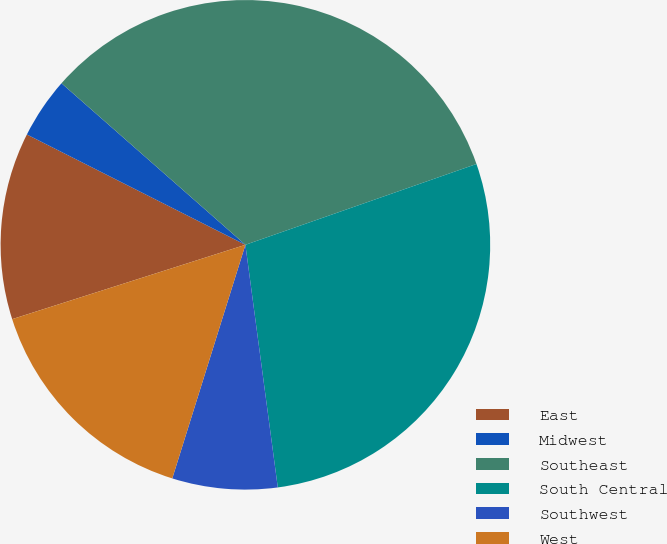Convert chart. <chart><loc_0><loc_0><loc_500><loc_500><pie_chart><fcel>East<fcel>Midwest<fcel>Southeast<fcel>South Central<fcel>Southwest<fcel>West<nl><fcel>12.35%<fcel>4.03%<fcel>33.17%<fcel>28.24%<fcel>6.94%<fcel>15.26%<nl></chart> 